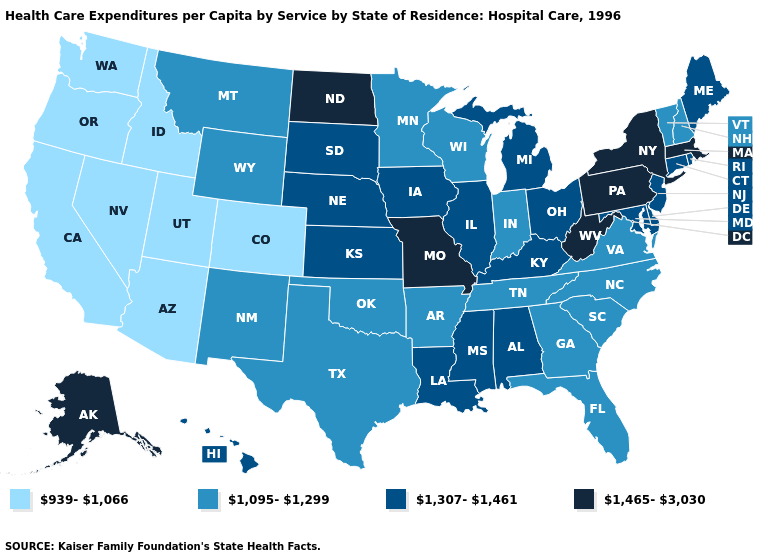Name the states that have a value in the range 1,307-1,461?
Short answer required. Alabama, Connecticut, Delaware, Hawaii, Illinois, Iowa, Kansas, Kentucky, Louisiana, Maine, Maryland, Michigan, Mississippi, Nebraska, New Jersey, Ohio, Rhode Island, South Dakota. Does Utah have the highest value in the USA?
Answer briefly. No. Which states have the lowest value in the USA?
Be succinct. Arizona, California, Colorado, Idaho, Nevada, Oregon, Utah, Washington. Does Indiana have the lowest value in the USA?
Keep it brief. No. What is the value of New Hampshire?
Short answer required. 1,095-1,299. Name the states that have a value in the range 1,307-1,461?
Quick response, please. Alabama, Connecticut, Delaware, Hawaii, Illinois, Iowa, Kansas, Kentucky, Louisiana, Maine, Maryland, Michigan, Mississippi, Nebraska, New Jersey, Ohio, Rhode Island, South Dakota. What is the highest value in states that border Mississippi?
Quick response, please. 1,307-1,461. Name the states that have a value in the range 939-1,066?
Quick response, please. Arizona, California, Colorado, Idaho, Nevada, Oregon, Utah, Washington. What is the value of West Virginia?
Quick response, please. 1,465-3,030. Does New Hampshire have the highest value in the Northeast?
Give a very brief answer. No. How many symbols are there in the legend?
Be succinct. 4. What is the lowest value in states that border Minnesota?
Short answer required. 1,095-1,299. Does the map have missing data?
Quick response, please. No. Name the states that have a value in the range 1,095-1,299?
Quick response, please. Arkansas, Florida, Georgia, Indiana, Minnesota, Montana, New Hampshire, New Mexico, North Carolina, Oklahoma, South Carolina, Tennessee, Texas, Vermont, Virginia, Wisconsin, Wyoming. What is the value of Massachusetts?
Keep it brief. 1,465-3,030. 